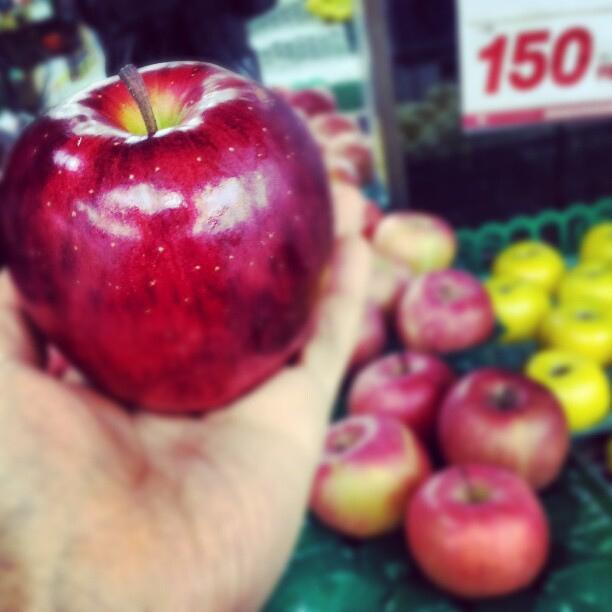What kind of fruit is this?
Concise answer only. Apple. What color is the numbers 150?
Give a very brief answer. Red. Does the picture have blue oranges?
Write a very short answer. No. 